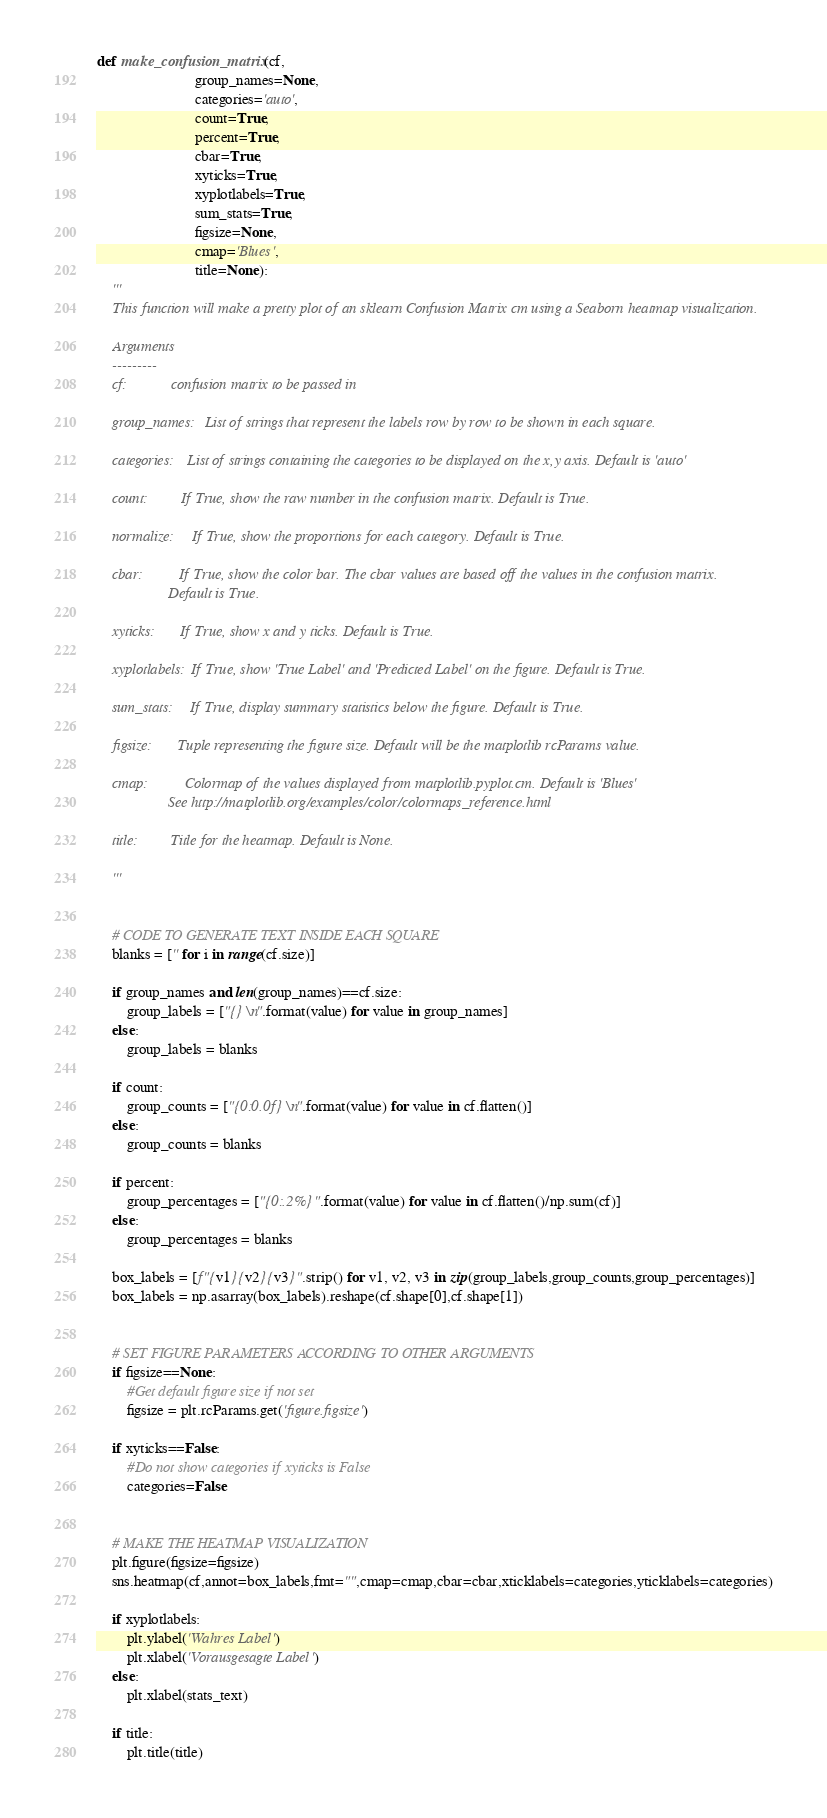<code> <loc_0><loc_0><loc_500><loc_500><_Python_>
def make_confusion_matrix(cf,
                          group_names=None,
                          categories='auto',
                          count=True,
                          percent=True,
                          cbar=True,
                          xyticks=True,
                          xyplotlabels=True,
                          sum_stats=True,
                          figsize=None,
                          cmap='Blues',
                          title=None):
    '''
    This function will make a pretty plot of an sklearn Confusion Matrix cm using a Seaborn heatmap visualization.

    Arguments
    ---------
    cf:            confusion matrix to be passed in

    group_names:   List of strings that represent the labels row by row to be shown in each square.

    categories:    List of strings containing the categories to be displayed on the x,y axis. Default is 'auto'

    count:         If True, show the raw number in the confusion matrix. Default is True.

    normalize:     If True, show the proportions for each category. Default is True.

    cbar:          If True, show the color bar. The cbar values are based off the values in the confusion matrix.
                   Default is True.

    xyticks:       If True, show x and y ticks. Default is True.

    xyplotlabels:  If True, show 'True Label' and 'Predicted Label' on the figure. Default is True.

    sum_stats:     If True, display summary statistics below the figure. Default is True.

    figsize:       Tuple representing the figure size. Default will be the matplotlib rcParams value.

    cmap:          Colormap of the values displayed from matplotlib.pyplot.cm. Default is 'Blues'
                   See http://matplotlib.org/examples/color/colormaps_reference.html
                   
    title:         Title for the heatmap. Default is None.

    '''


    # CODE TO GENERATE TEXT INSIDE EACH SQUARE
    blanks = ['' for i in range(cf.size)]

    if group_names and len(group_names)==cf.size:
        group_labels = ["{}\n".format(value) for value in group_names]
    else:
        group_labels = blanks

    if count:
        group_counts = ["{0:0.0f}\n".format(value) for value in cf.flatten()]
    else:
        group_counts = blanks

    if percent:
        group_percentages = ["{0:.2%}".format(value) for value in cf.flatten()/np.sum(cf)]
    else:
        group_percentages = blanks

    box_labels = [f"{v1}{v2}{v3}".strip() for v1, v2, v3 in zip(group_labels,group_counts,group_percentages)]
    box_labels = np.asarray(box_labels).reshape(cf.shape[0],cf.shape[1])


    # SET FIGURE PARAMETERS ACCORDING TO OTHER ARGUMENTS
    if figsize==None:
        #Get default figure size if not set
        figsize = plt.rcParams.get('figure.figsize')

    if xyticks==False:
        #Do not show categories if xyticks is False
        categories=False


    # MAKE THE HEATMAP VISUALIZATION
    plt.figure(figsize=figsize)
    sns.heatmap(cf,annot=box_labels,fmt="",cmap=cmap,cbar=cbar,xticklabels=categories,yticklabels=categories)

    if xyplotlabels:
        plt.ylabel('Wahres Label')
        plt.xlabel('Vorausgesagte Label')
    else:
        plt.xlabel(stats_text)
    
    if title:
        plt.title(title)</code> 